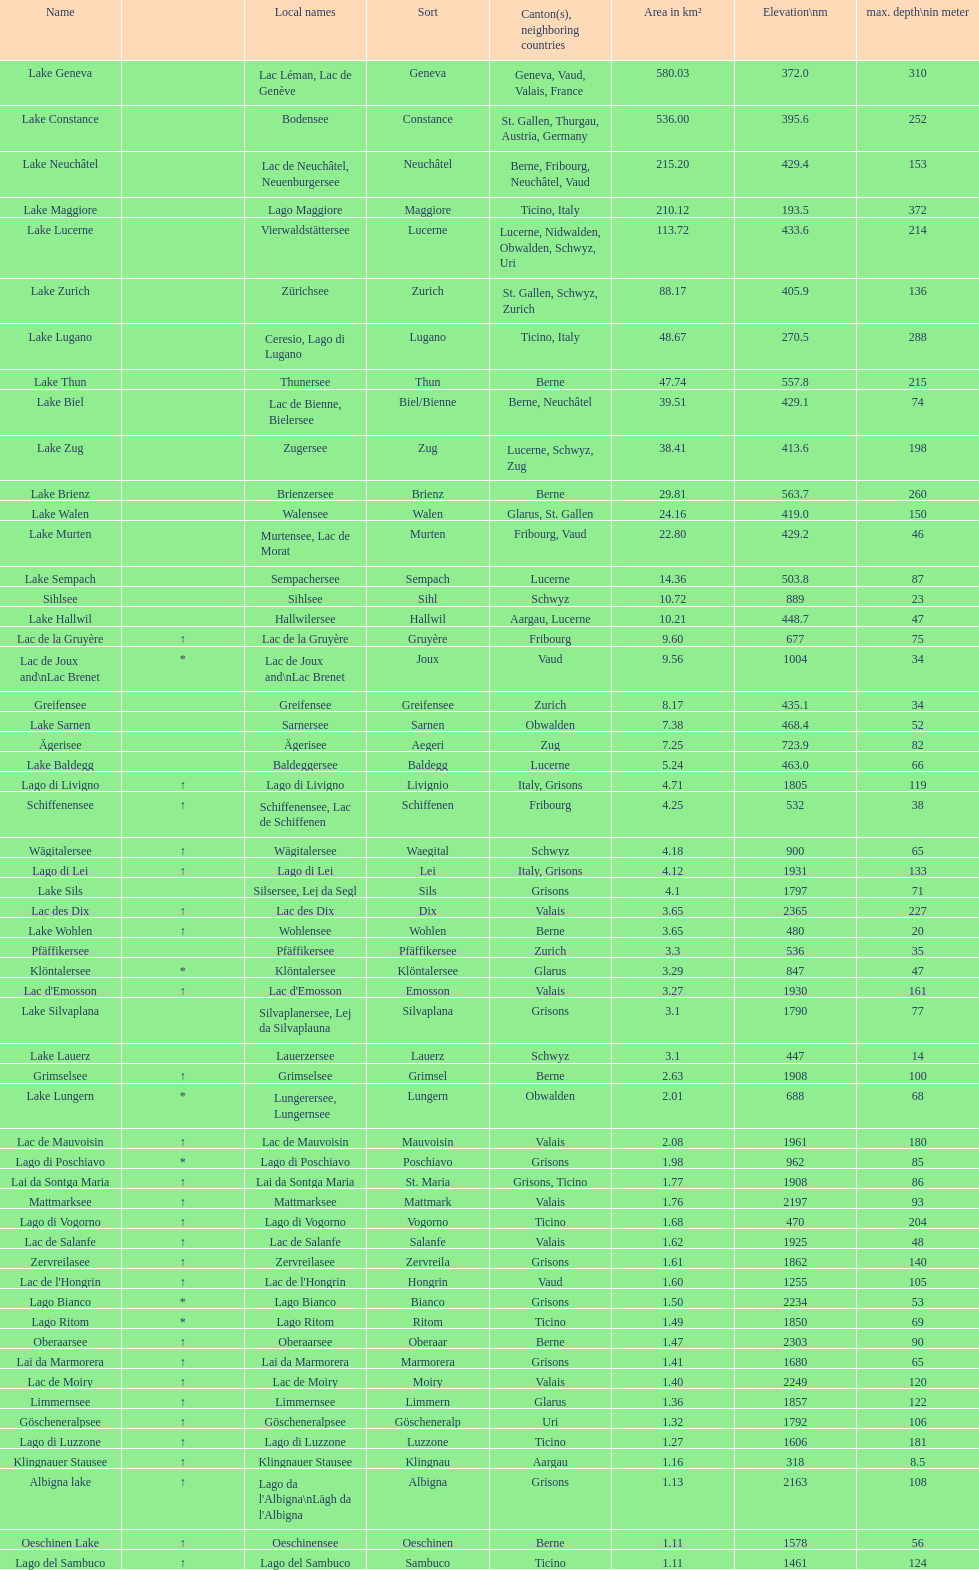Write the full table. {'header': ['Name', '', 'Local names', 'Sort', 'Canton(s), neighboring countries', 'Area in km²', 'Elevation\\nm', 'max. depth\\nin meter'], 'rows': [['Lake Geneva', '', 'Lac Léman, Lac de Genève', 'Geneva', 'Geneva, Vaud, Valais, France', '580.03', '372.0', '310'], ['Lake Constance', '', 'Bodensee', 'Constance', 'St. Gallen, Thurgau, Austria, Germany', '536.00', '395.6', '252'], ['Lake Neuchâtel', '', 'Lac de Neuchâtel, Neuenburgersee', 'Neuchâtel', 'Berne, Fribourg, Neuchâtel, Vaud', '215.20', '429.4', '153'], ['Lake Maggiore', '', 'Lago Maggiore', 'Maggiore', 'Ticino, Italy', '210.12', '193.5', '372'], ['Lake Lucerne', '', 'Vierwaldstättersee', 'Lucerne', 'Lucerne, Nidwalden, Obwalden, Schwyz, Uri', '113.72', '433.6', '214'], ['Lake Zurich', '', 'Zürichsee', 'Zurich', 'St. Gallen, Schwyz, Zurich', '88.17', '405.9', '136'], ['Lake Lugano', '', 'Ceresio, Lago di Lugano', 'Lugano', 'Ticino, Italy', '48.67', '270.5', '288'], ['Lake Thun', '', 'Thunersee', 'Thun', 'Berne', '47.74', '557.8', '215'], ['Lake Biel', '', 'Lac de Bienne, Bielersee', 'Biel/Bienne', 'Berne, Neuchâtel', '39.51', '429.1', '74'], ['Lake Zug', '', 'Zugersee', 'Zug', 'Lucerne, Schwyz, Zug', '38.41', '413.6', '198'], ['Lake Brienz', '', 'Brienzersee', 'Brienz', 'Berne', '29.81', '563.7', '260'], ['Lake Walen', '', 'Walensee', 'Walen', 'Glarus, St. Gallen', '24.16', '419.0', '150'], ['Lake Murten', '', 'Murtensee, Lac de Morat', 'Murten', 'Fribourg, Vaud', '22.80', '429.2', '46'], ['Lake Sempach', '', 'Sempachersee', 'Sempach', 'Lucerne', '14.36', '503.8', '87'], ['Sihlsee', '', 'Sihlsee', 'Sihl', 'Schwyz', '10.72', '889', '23'], ['Lake Hallwil', '', 'Hallwilersee', 'Hallwil', 'Aargau, Lucerne', '10.21', '448.7', '47'], ['Lac de la Gruyère', '↑', 'Lac de la Gruyère', 'Gruyère', 'Fribourg', '9.60', '677', '75'], ['Lac de Joux and\\nLac Brenet', '*', 'Lac de Joux and\\nLac Brenet', 'Joux', 'Vaud', '9.56', '1004', '34'], ['Greifensee', '', 'Greifensee', 'Greifensee', 'Zurich', '8.17', '435.1', '34'], ['Lake Sarnen', '', 'Sarnersee', 'Sarnen', 'Obwalden', '7.38', '468.4', '52'], ['Ägerisee', '', 'Ägerisee', 'Aegeri', 'Zug', '7.25', '723.9', '82'], ['Lake Baldegg', '', 'Baldeggersee', 'Baldegg', 'Lucerne', '5.24', '463.0', '66'], ['Lago di Livigno', '↑', 'Lago di Livigno', 'Livignio', 'Italy, Grisons', '4.71', '1805', '119'], ['Schiffenensee', '↑', 'Schiffenensee, Lac de Schiffenen', 'Schiffenen', 'Fribourg', '4.25', '532', '38'], ['Wägitalersee', '↑', 'Wägitalersee', 'Waegital', 'Schwyz', '4.18', '900', '65'], ['Lago di Lei', '↑', 'Lago di Lei', 'Lei', 'Italy, Grisons', '4.12', '1931', '133'], ['Lake Sils', '', 'Silsersee, Lej da Segl', 'Sils', 'Grisons', '4.1', '1797', '71'], ['Lac des Dix', '↑', 'Lac des Dix', 'Dix', 'Valais', '3.65', '2365', '227'], ['Lake Wohlen', '↑', 'Wohlensee', 'Wohlen', 'Berne', '3.65', '480', '20'], ['Pfäffikersee', '', 'Pfäffikersee', 'Pfäffikersee', 'Zurich', '3.3', '536', '35'], ['Klöntalersee', '*', 'Klöntalersee', 'Klöntalersee', 'Glarus', '3.29', '847', '47'], ["Lac d'Emosson", '↑', "Lac d'Emosson", 'Emosson', 'Valais', '3.27', '1930', '161'], ['Lake Silvaplana', '', 'Silvaplanersee, Lej da Silvaplauna', 'Silvaplana', 'Grisons', '3.1', '1790', '77'], ['Lake Lauerz', '', 'Lauerzersee', 'Lauerz', 'Schwyz', '3.1', '447', '14'], ['Grimselsee', '↑', 'Grimselsee', 'Grimsel', 'Berne', '2.63', '1908', '100'], ['Lake Lungern', '*', 'Lungerersee, Lungernsee', 'Lungern', 'Obwalden', '2.01', '688', '68'], ['Lac de Mauvoisin', '↑', 'Lac de Mauvoisin', 'Mauvoisin', 'Valais', '2.08', '1961', '180'], ['Lago di Poschiavo', '*', 'Lago di Poschiavo', 'Poschiavo', 'Grisons', '1.98', '962', '85'], ['Lai da Sontga Maria', '↑', 'Lai da Sontga Maria', 'St. Maria', 'Grisons, Ticino', '1.77', '1908', '86'], ['Mattmarksee', '↑', 'Mattmarksee', 'Mattmark', 'Valais', '1.76', '2197', '93'], ['Lago di Vogorno', '↑', 'Lago di Vogorno', 'Vogorno', 'Ticino', '1.68', '470', '204'], ['Lac de Salanfe', '↑', 'Lac de Salanfe', 'Salanfe', 'Valais', '1.62', '1925', '48'], ['Zervreilasee', '↑', 'Zervreilasee', 'Zervreila', 'Grisons', '1.61', '1862', '140'], ["Lac de l'Hongrin", '↑', "Lac de l'Hongrin", 'Hongrin', 'Vaud', '1.60', '1255', '105'], ['Lago Bianco', '*', 'Lago Bianco', 'Bianco', 'Grisons', '1.50', '2234', '53'], ['Lago Ritom', '*', 'Lago Ritom', 'Ritom', 'Ticino', '1.49', '1850', '69'], ['Oberaarsee', '↑', 'Oberaarsee', 'Oberaar', 'Berne', '1.47', '2303', '90'], ['Lai da Marmorera', '↑', 'Lai da Marmorera', 'Marmorera', 'Grisons', '1.41', '1680', '65'], ['Lac de Moiry', '↑', 'Lac de Moiry', 'Moiry', 'Valais', '1.40', '2249', '120'], ['Limmernsee', '↑', 'Limmernsee', 'Limmern', 'Glarus', '1.36', '1857', '122'], ['Göscheneralpsee', '↑', 'Göscheneralpsee', 'Göscheneralp', 'Uri', '1.32', '1792', '106'], ['Lago di Luzzone', '↑', 'Lago di Luzzone', 'Luzzone', 'Ticino', '1.27', '1606', '181'], ['Klingnauer Stausee', '↑', 'Klingnauer Stausee', 'Klingnau', 'Aargau', '1.16', '318', '8.5'], ['Albigna lake', '↑', "Lago da l'Albigna\\nLägh da l'Albigna", 'Albigna', 'Grisons', '1.13', '2163', '108'], ['Oeschinen Lake', '↑', 'Oeschinensee', 'Oeschinen', 'Berne', '1.11', '1578', '56'], ['Lago del Sambuco', '↑', 'Lago del Sambuco', 'Sambuco', 'Ticino', '1.11', '1461', '124']]} How many lakes are there with an area smaller than 100 square kilometers? 51. 